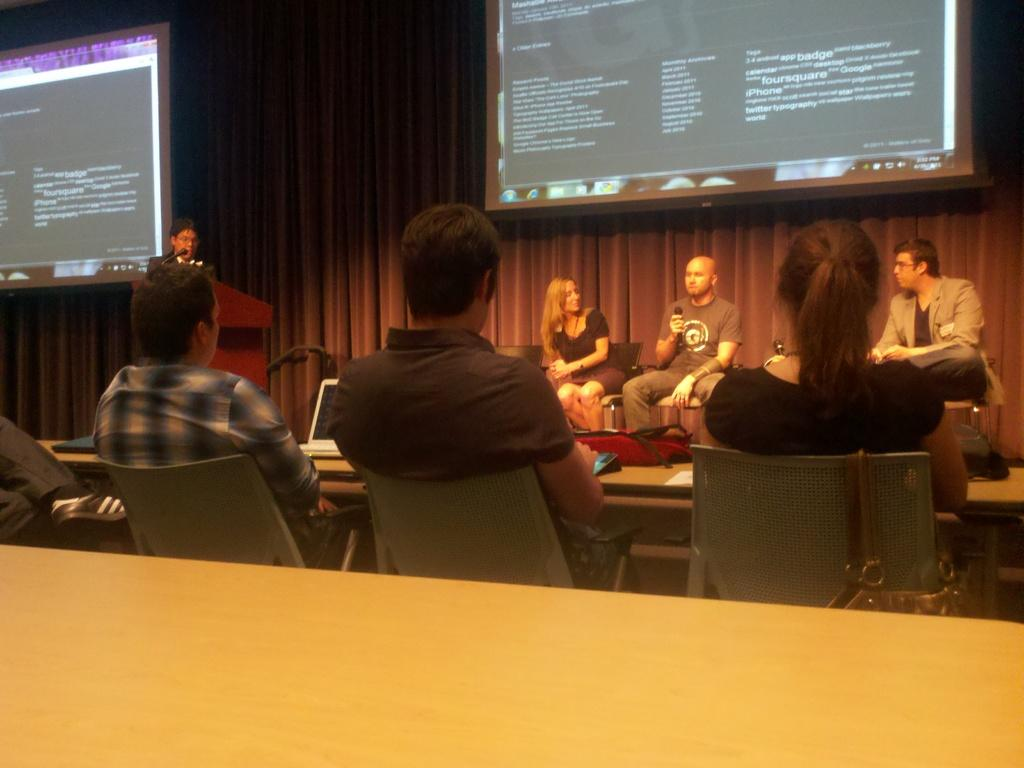What are the people in the image doing? The people in the image are sitting on chairs. What can be seen on the screen in the image? The screen is visible in the image, but its content is not specified. What is the person standing in front of in the image? The person is standing in front of a podium in the image. Who is the creator of the sun in the image? There is no sun present in the image, and therefore no creator can be identified. What type of church is depicted in the image? There is no church present in the image. 